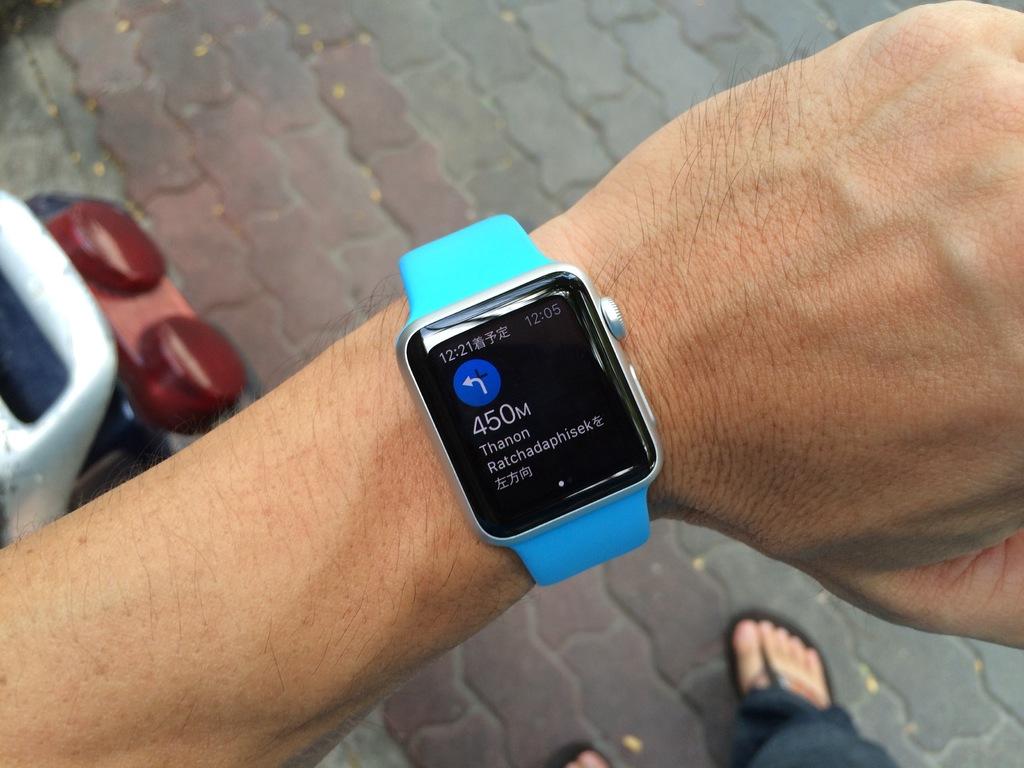What does the time say on that smartwatch?
Ensure brevity in your answer.  12:21. 